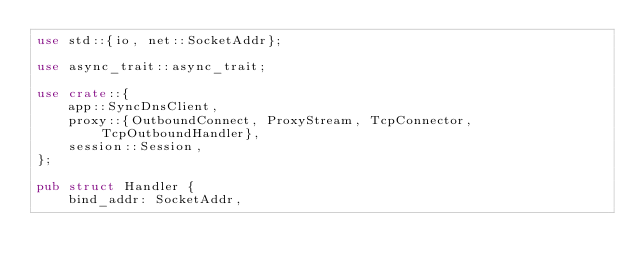<code> <loc_0><loc_0><loc_500><loc_500><_Rust_>use std::{io, net::SocketAddr};

use async_trait::async_trait;

use crate::{
    app::SyncDnsClient,
    proxy::{OutboundConnect, ProxyStream, TcpConnector, TcpOutboundHandler},
    session::Session,
};

pub struct Handler {
    bind_addr: SocketAddr,</code> 